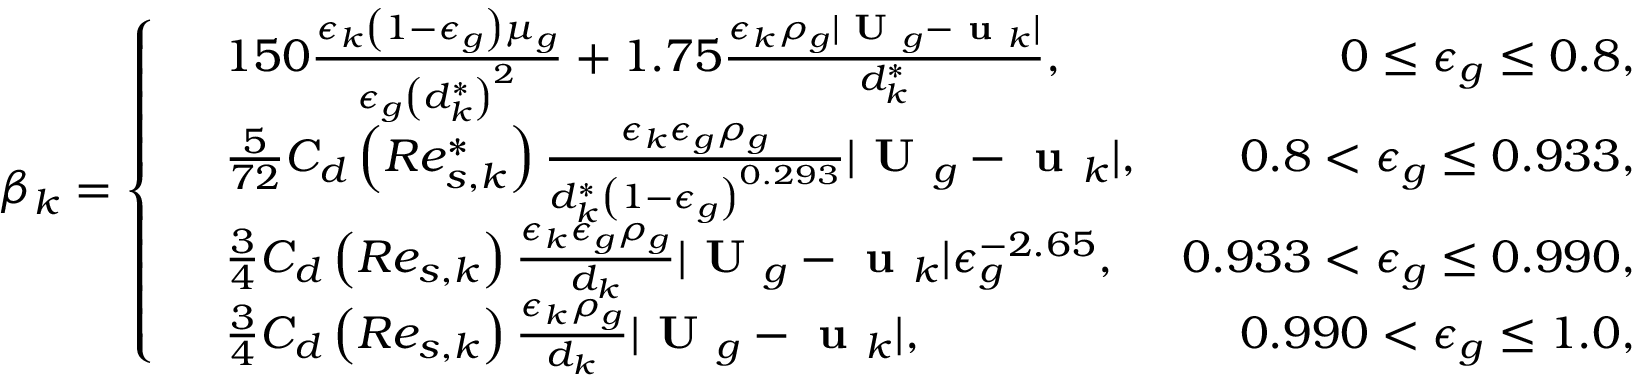<formula> <loc_0><loc_0><loc_500><loc_500>\beta _ { k } = \left \{ \begin{array} { r l r } & { 1 5 0 \frac { \epsilon _ { k } \left ( 1 - \epsilon _ { g } \right ) \mu _ { g } } { \epsilon _ { g } \left ( d _ { k } ^ { * } \right ) ^ { 2 } } + 1 . 7 5 \frac { \epsilon _ { k } \rho _ { g } | U _ { g } - u _ { k } | } { d _ { k } ^ { * } } , } & { 0 \leq \epsilon _ { g } \leq 0 . 8 , } \\ & { \frac { 5 } { 7 2 } C _ { d } \left ( R e _ { s , k } ^ { * } \right ) \frac { \epsilon _ { k } \epsilon _ { g } \rho _ { g } } { d _ { k } ^ { * } \left ( 1 - \epsilon _ { g } \right ) ^ { 0 . 2 9 3 } } | U _ { g } - u _ { k } | , } & { 0 . 8 < \epsilon _ { g } \leq 0 . 9 3 3 , } \\ & { \frac { 3 } { 4 } C _ { d } \left ( R e _ { s , k } \right ) \frac { \epsilon _ { k } \epsilon _ { g } \rho _ { g } } { d _ { k } } | U _ { g } - u _ { k } | \epsilon _ { g } ^ { - 2 . 6 5 } , } & { 0 . 9 3 3 < \epsilon _ { g } \leq 0 . 9 9 0 , } \\ & { \frac { 3 } { 4 } C _ { d } \left ( R e _ { s , k } \right ) \frac { \epsilon _ { k } \rho _ { g } } { d _ { k } } | U _ { g } - u _ { k } | , } & { 0 . 9 9 0 < \epsilon _ { g } \leq 1 . 0 , } \end{array}</formula> 